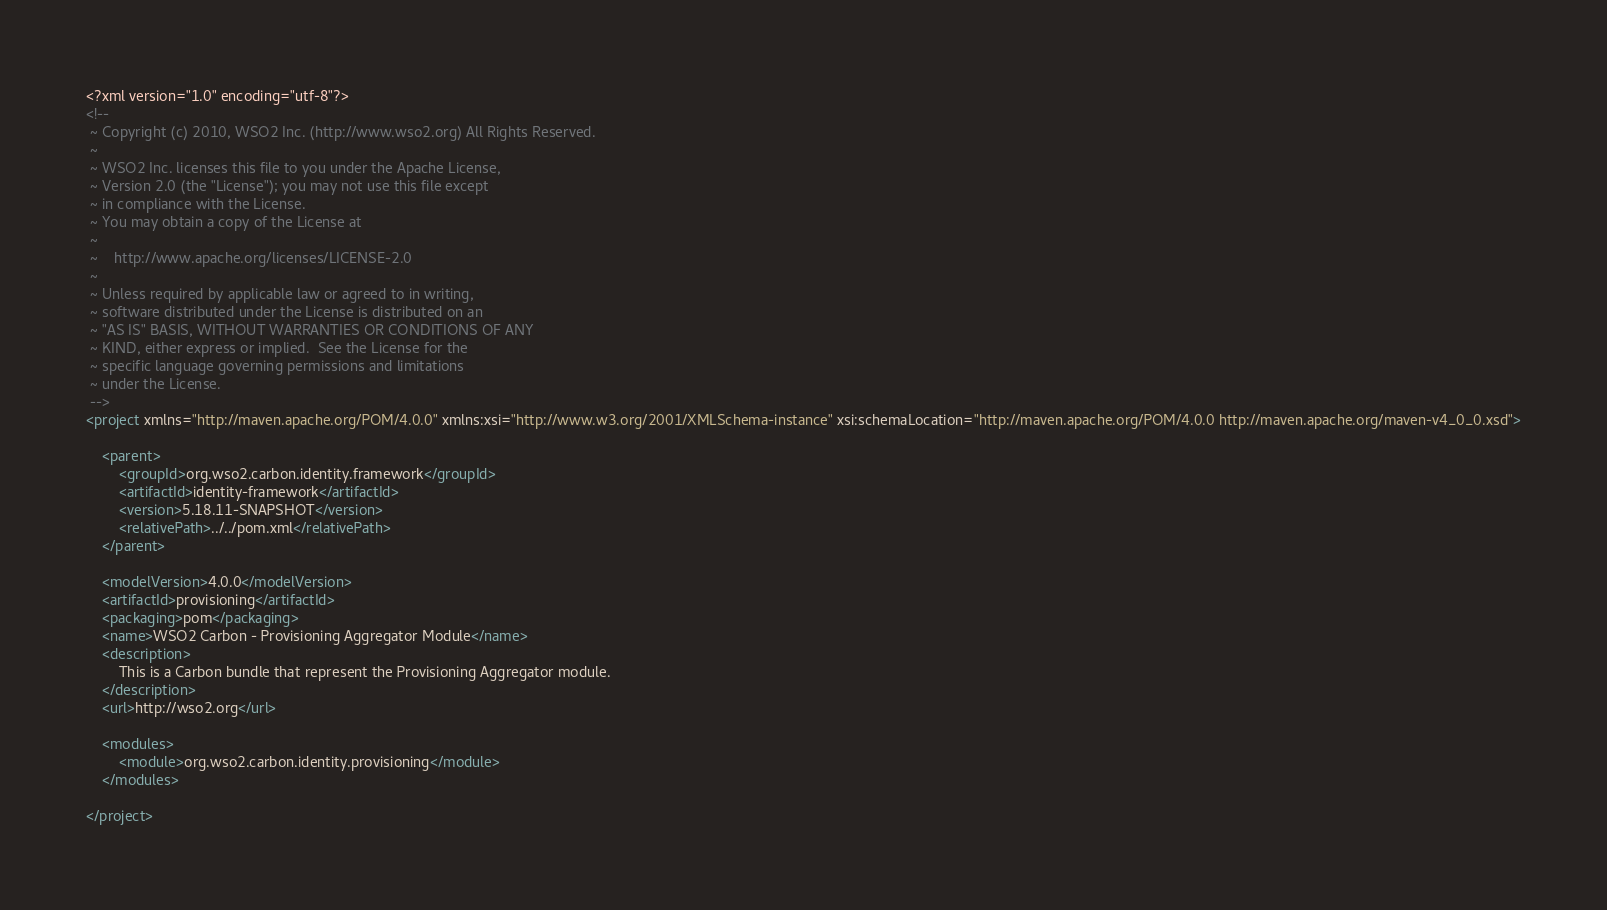<code> <loc_0><loc_0><loc_500><loc_500><_XML_><?xml version="1.0" encoding="utf-8"?>
<!--
 ~ Copyright (c) 2010, WSO2 Inc. (http://www.wso2.org) All Rights Reserved.
 ~
 ~ WSO2 Inc. licenses this file to you under the Apache License,
 ~ Version 2.0 (the "License"); you may not use this file except
 ~ in compliance with the License.
 ~ You may obtain a copy of the License at
 ~
 ~    http://www.apache.org/licenses/LICENSE-2.0
 ~
 ~ Unless required by applicable law or agreed to in writing,
 ~ software distributed under the License is distributed on an
 ~ "AS IS" BASIS, WITHOUT WARRANTIES OR CONDITIONS OF ANY
 ~ KIND, either express or implied.  See the License for the
 ~ specific language governing permissions and limitations
 ~ under the License.
 -->
<project xmlns="http://maven.apache.org/POM/4.0.0" xmlns:xsi="http://www.w3.org/2001/XMLSchema-instance" xsi:schemaLocation="http://maven.apache.org/POM/4.0.0 http://maven.apache.org/maven-v4_0_0.xsd">

    <parent>
        <groupId>org.wso2.carbon.identity.framework</groupId>
        <artifactId>identity-framework</artifactId>
        <version>5.18.11-SNAPSHOT</version>
        <relativePath>../../pom.xml</relativePath>
    </parent>

    <modelVersion>4.0.0</modelVersion>
    <artifactId>provisioning</artifactId>
    <packaging>pom</packaging>
    <name>WSO2 Carbon - Provisioning Aggregator Module</name>
    <description>
        This is a Carbon bundle that represent the Provisioning Aggregator module.
    </description>
    <url>http://wso2.org</url>

    <modules>
        <module>org.wso2.carbon.identity.provisioning</module>
    </modules>

</project>
</code> 